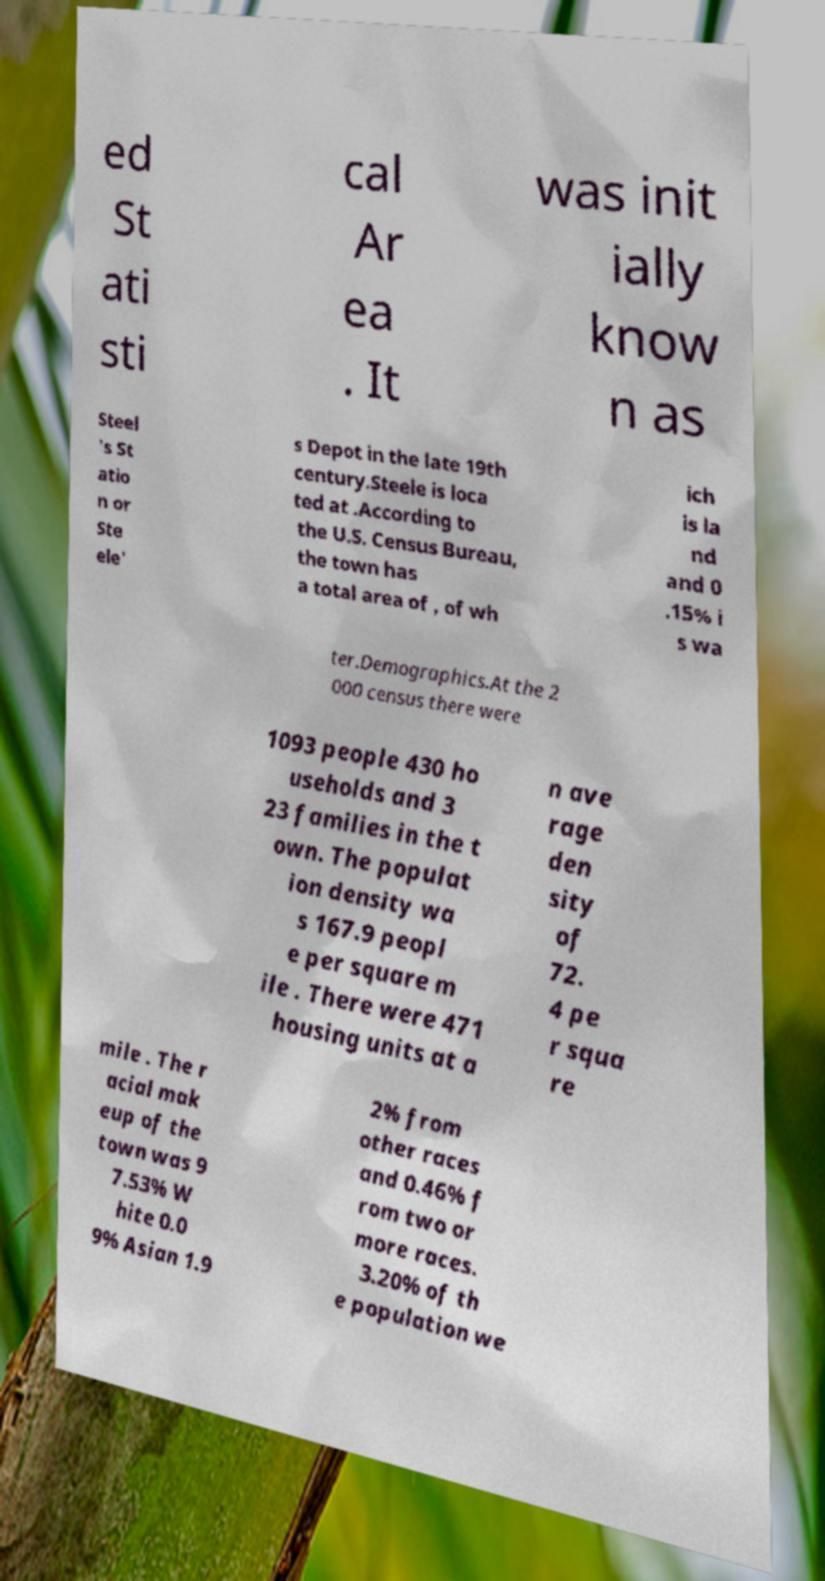I need the written content from this picture converted into text. Can you do that? ed St ati sti cal Ar ea . It was init ially know n as Steel 's St atio n or Ste ele' s Depot in the late 19th century.Steele is loca ted at .According to the U.S. Census Bureau, the town has a total area of , of wh ich is la nd and 0 .15% i s wa ter.Demographics.At the 2 000 census there were 1093 people 430 ho useholds and 3 23 families in the t own. The populat ion density wa s 167.9 peopl e per square m ile . There were 471 housing units at a n ave rage den sity of 72. 4 pe r squa re mile . The r acial mak eup of the town was 9 7.53% W hite 0.0 9% Asian 1.9 2% from other races and 0.46% f rom two or more races. 3.20% of th e population we 